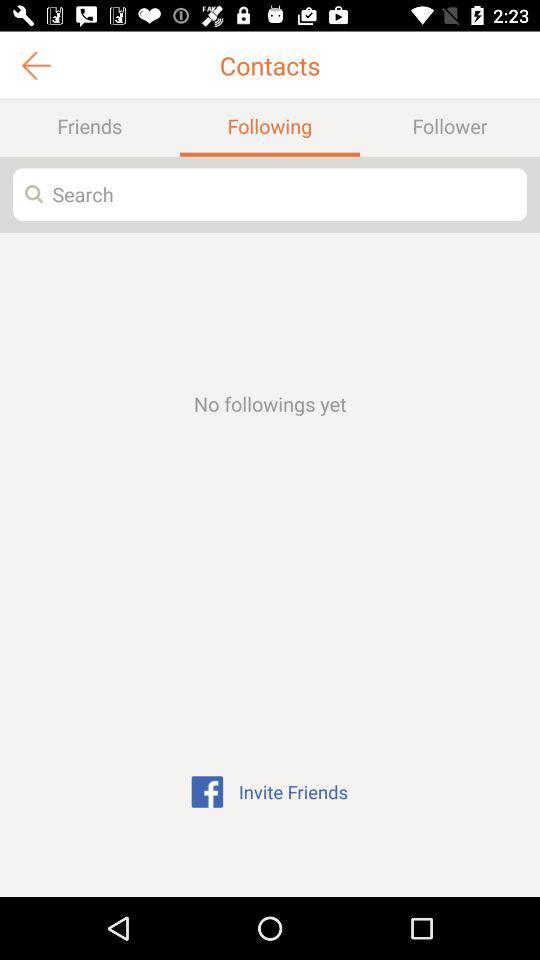What is the selected tab? The selected tab is "Following". 